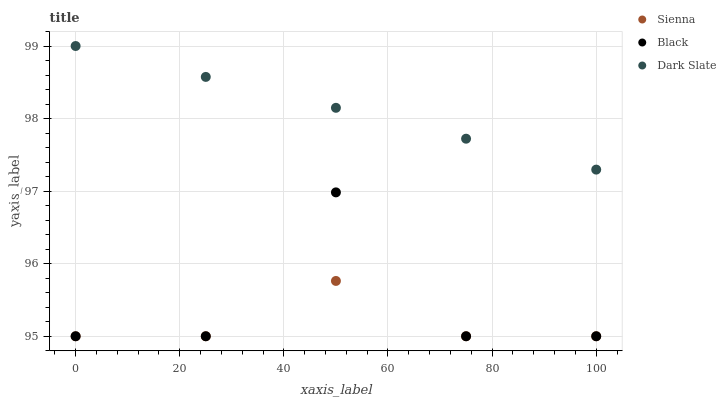Does Sienna have the minimum area under the curve?
Answer yes or no. Yes. Does Dark Slate have the maximum area under the curve?
Answer yes or no. Yes. Does Black have the minimum area under the curve?
Answer yes or no. No. Does Black have the maximum area under the curve?
Answer yes or no. No. Is Dark Slate the smoothest?
Answer yes or no. Yes. Is Black the roughest?
Answer yes or no. Yes. Is Black the smoothest?
Answer yes or no. No. Is Dark Slate the roughest?
Answer yes or no. No. Does Sienna have the lowest value?
Answer yes or no. Yes. Does Dark Slate have the lowest value?
Answer yes or no. No. Does Dark Slate have the highest value?
Answer yes or no. Yes. Does Black have the highest value?
Answer yes or no. No. Is Black less than Dark Slate?
Answer yes or no. Yes. Is Dark Slate greater than Black?
Answer yes or no. Yes. Does Sienna intersect Black?
Answer yes or no. Yes. Is Sienna less than Black?
Answer yes or no. No. Is Sienna greater than Black?
Answer yes or no. No. Does Black intersect Dark Slate?
Answer yes or no. No. 